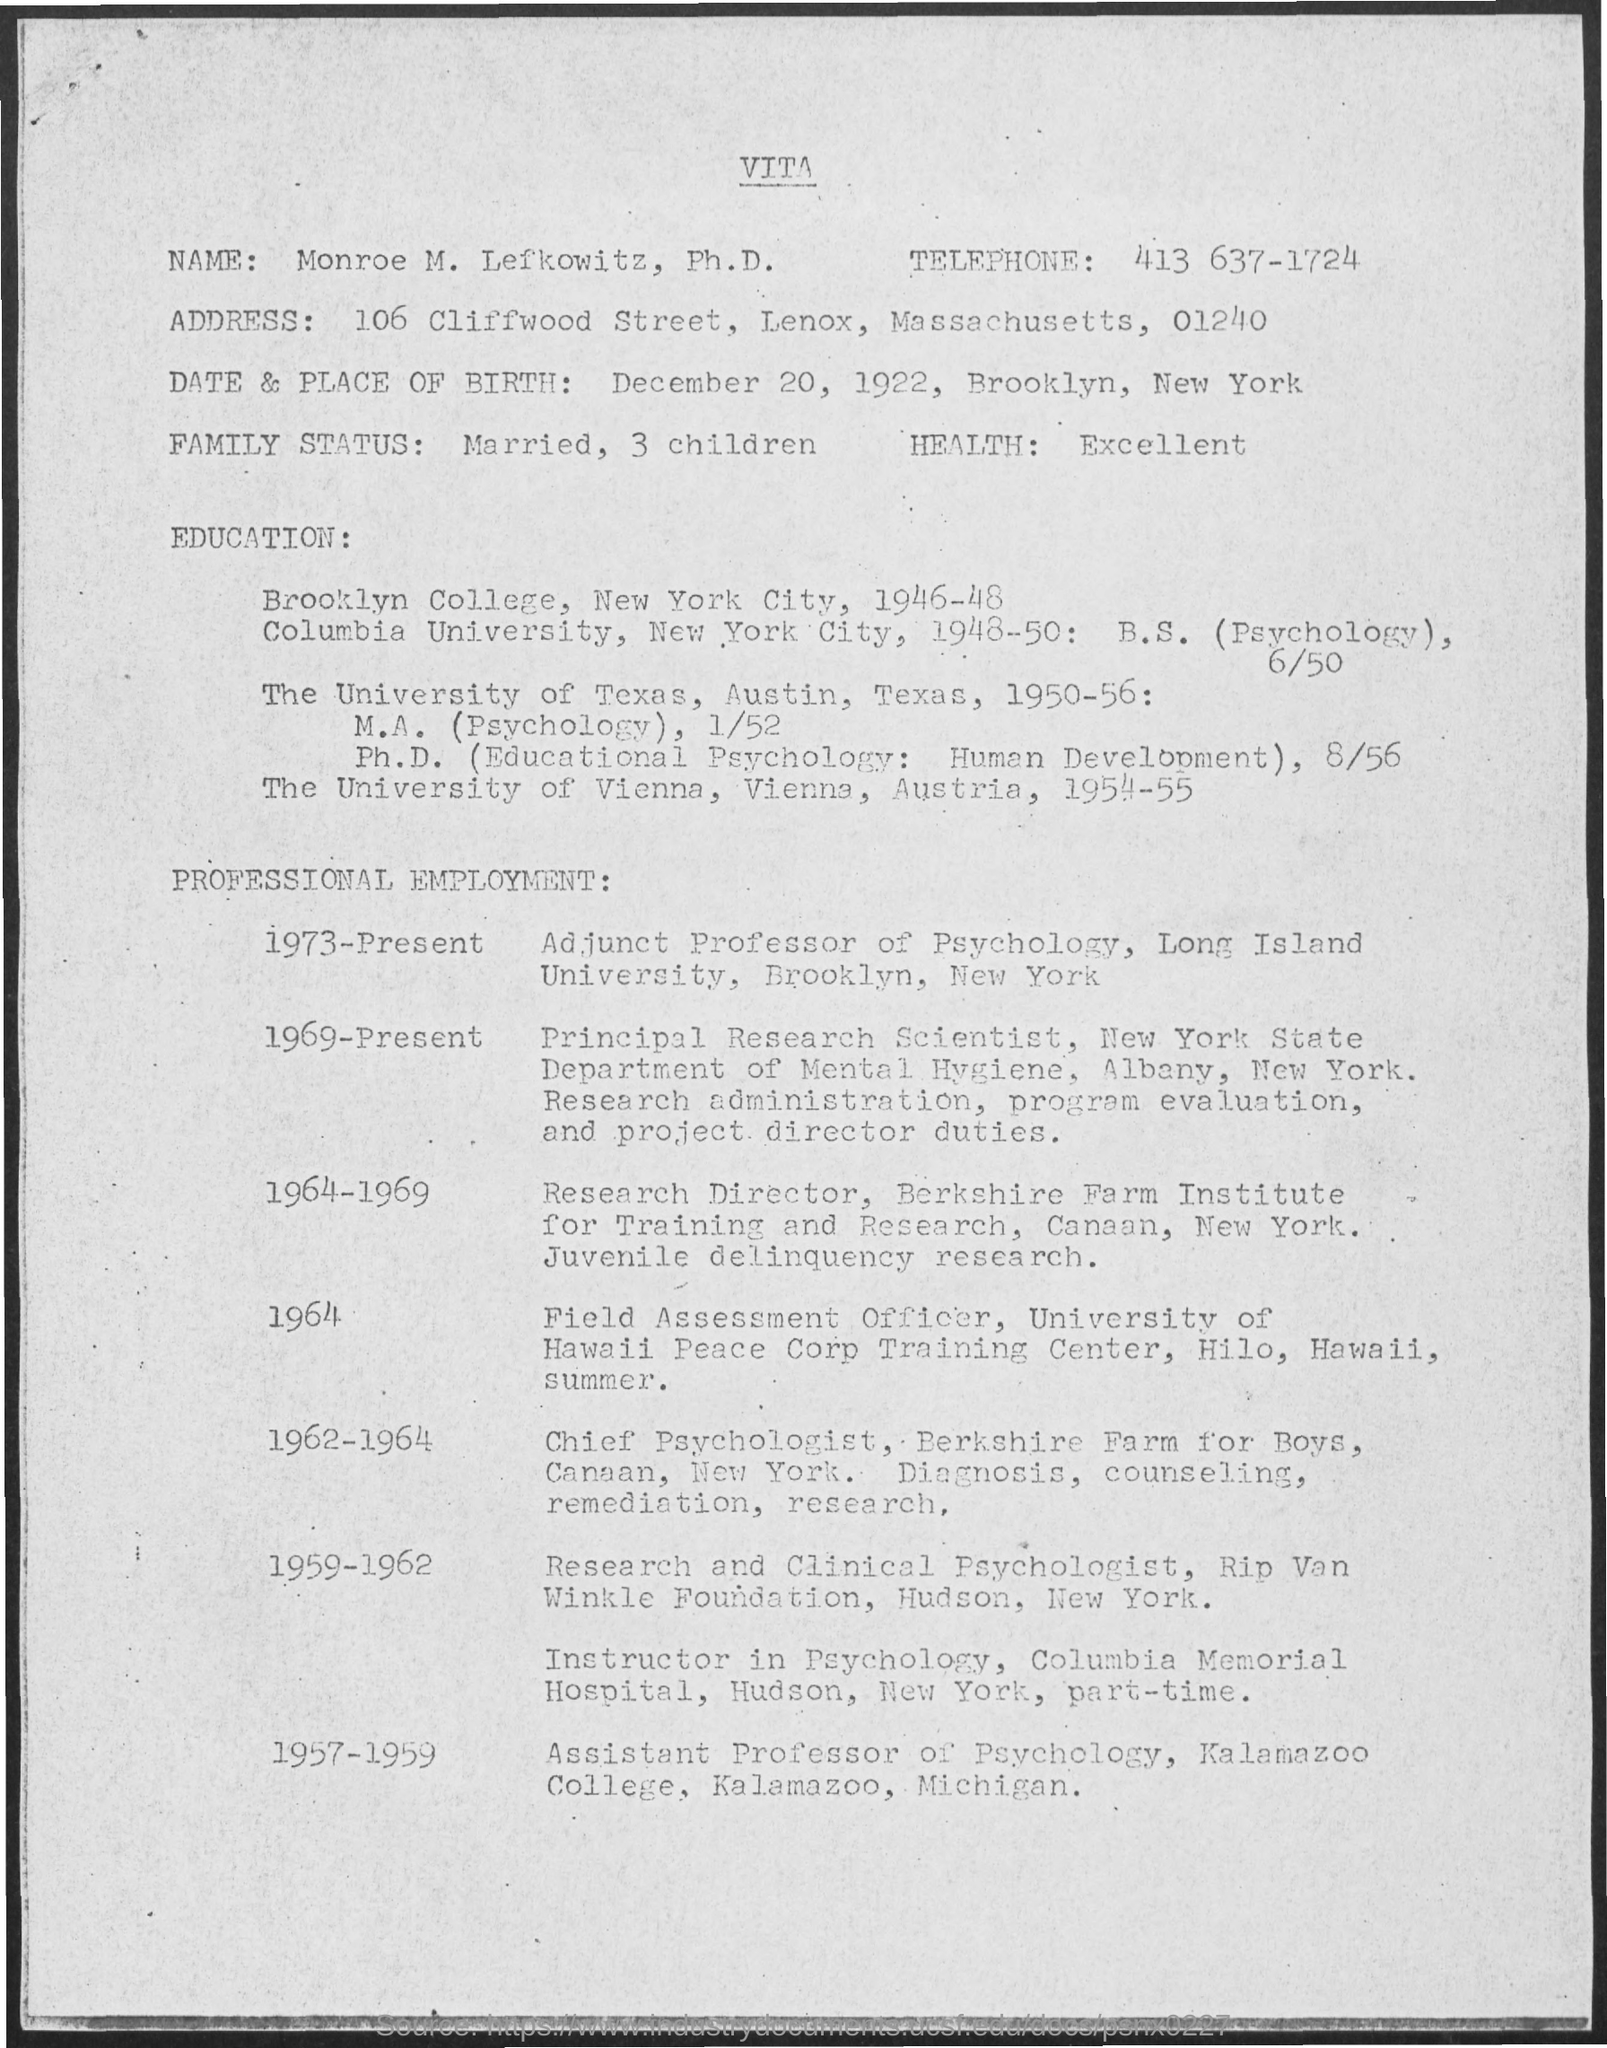What is the name of person in VITA?
Offer a very short reply. Monroe M. lefkowitz, Ph.D. What is the telephone no of Mr.Monroe?
Offer a very short reply. 413 637-1724. What is the date of birth of Mr.Monroe?
Your answer should be compact. December 20, 1922. What is the place of birth of Mr.Monroe?
Your answer should be compact. Brooklyn, New York. When did Mr.Monroe completed his M.A. (Psychology) & Ph.D?
Offer a very short reply. 1950-56. Where did Monroe complete Ph.D?
Keep it short and to the point. The university of vienna, vienna, austria. When did Monroe worked as Assistant Professor of Psychology?
Provide a short and direct response. 1957-1959. What is the profession of Monroe during 1973-Present?
Offer a terse response. Adjunct Professor of psychology, Long Island University, Brooklyn, Newyork. 